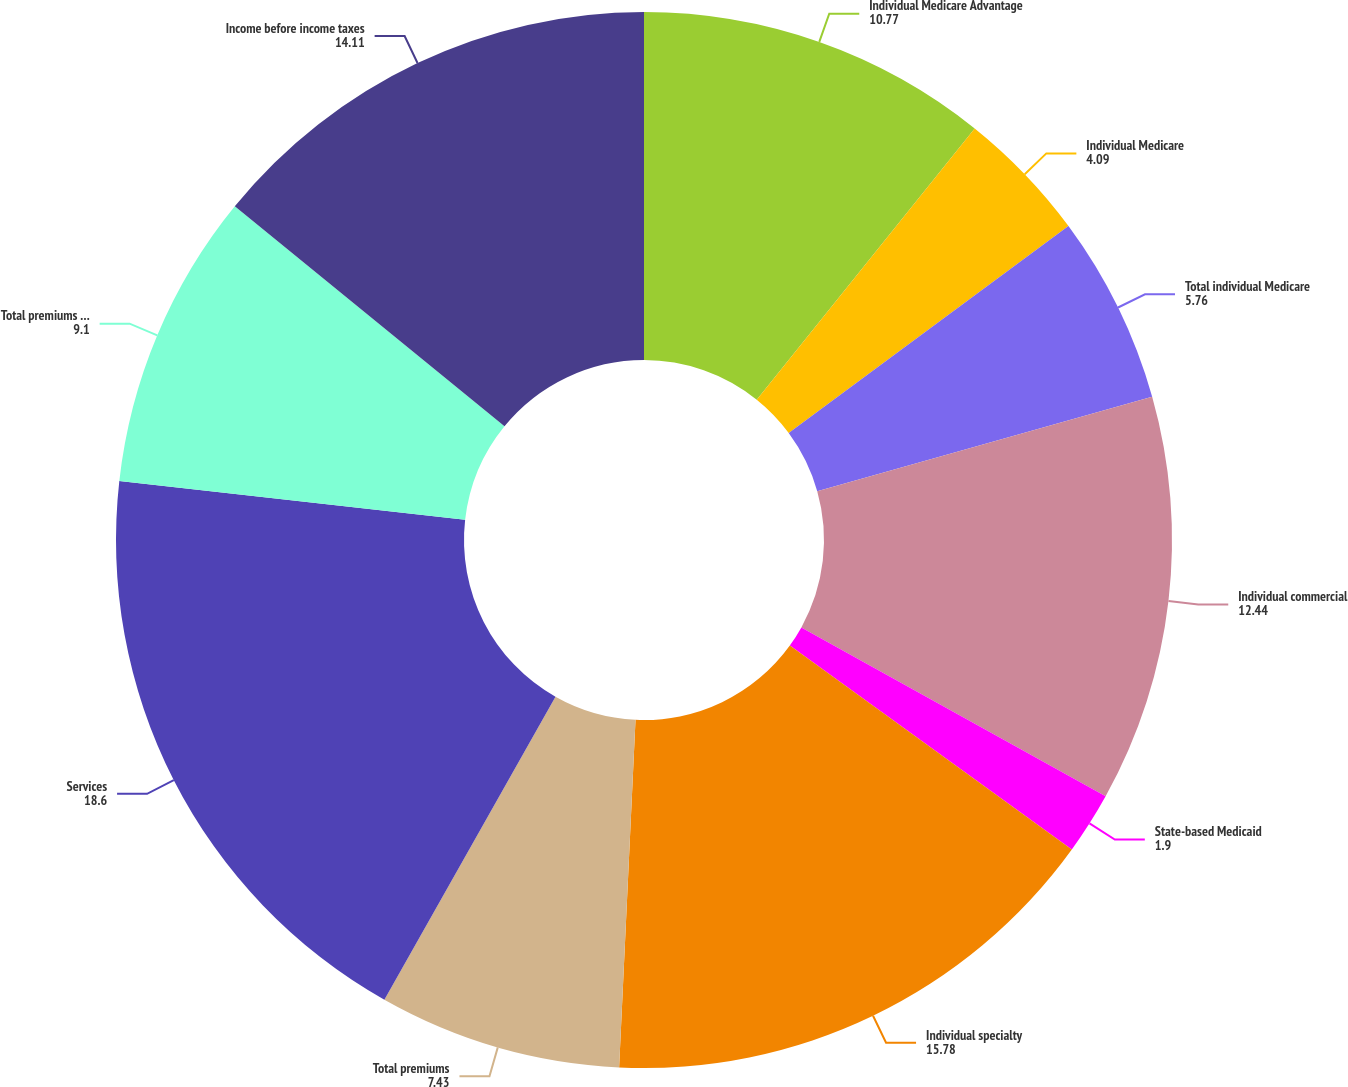Convert chart to OTSL. <chart><loc_0><loc_0><loc_500><loc_500><pie_chart><fcel>Individual Medicare Advantage<fcel>Individual Medicare<fcel>Total individual Medicare<fcel>Individual commercial<fcel>State-based Medicaid<fcel>Individual specialty<fcel>Total premiums<fcel>Services<fcel>Total premiums and services<fcel>Income before income taxes<nl><fcel>10.77%<fcel>4.09%<fcel>5.76%<fcel>12.44%<fcel>1.9%<fcel>15.78%<fcel>7.43%<fcel>18.6%<fcel>9.1%<fcel>14.11%<nl></chart> 